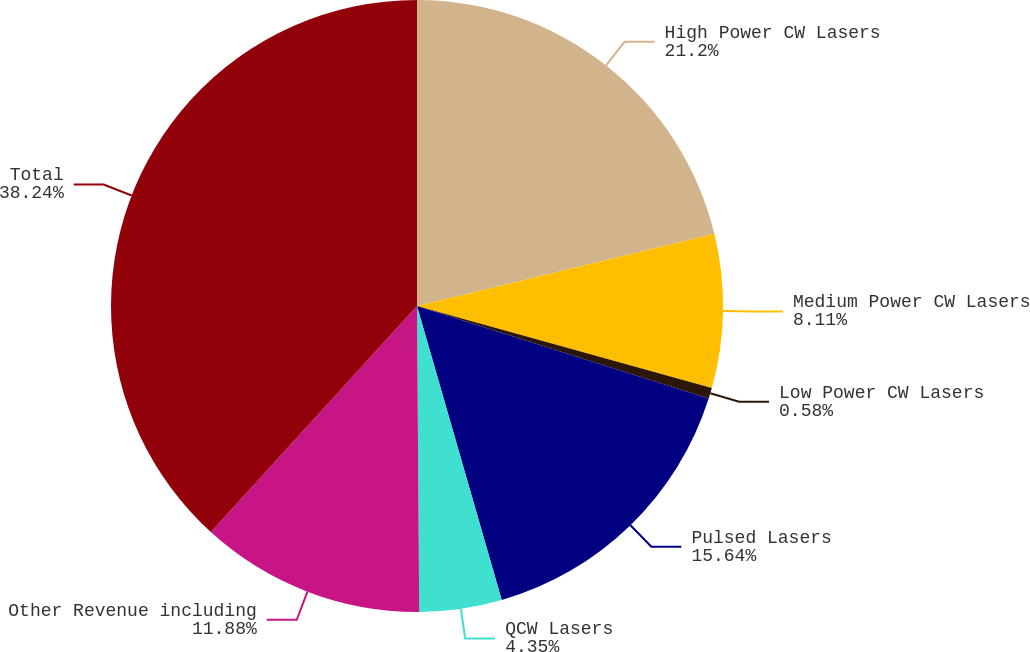<chart> <loc_0><loc_0><loc_500><loc_500><pie_chart><fcel>High Power CW Lasers<fcel>Medium Power CW Lasers<fcel>Low Power CW Lasers<fcel>Pulsed Lasers<fcel>QCW Lasers<fcel>Other Revenue including<fcel>Total<nl><fcel>21.2%<fcel>8.11%<fcel>0.58%<fcel>15.64%<fcel>4.35%<fcel>11.88%<fcel>38.23%<nl></chart> 